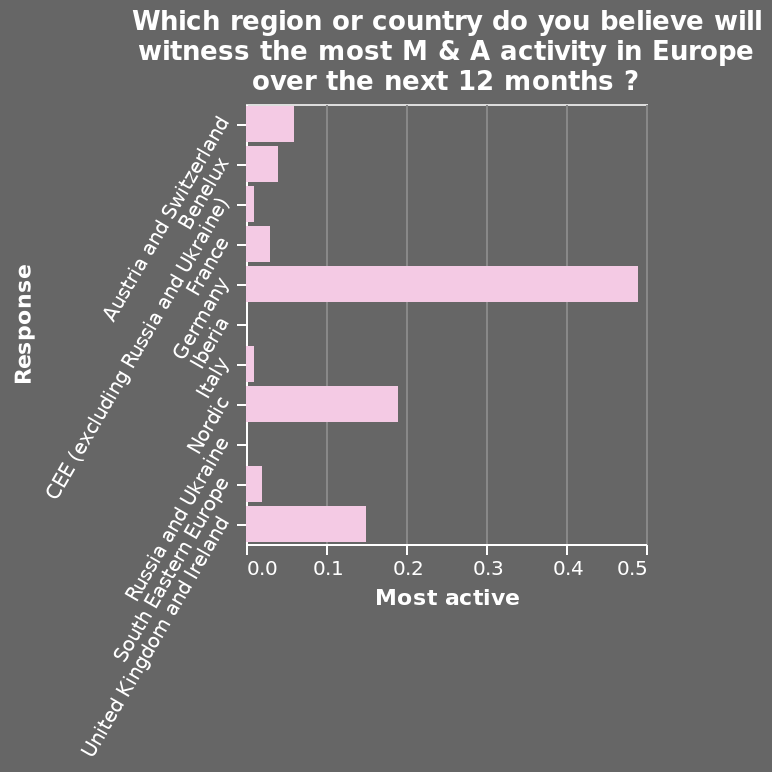<image>
What is the name of the bar graph?  The bar graph does not have a specific name mentioned in the description. What type of information does the graph display?  The graph displays only the information collected at a point in time, without any indication of a trend. 